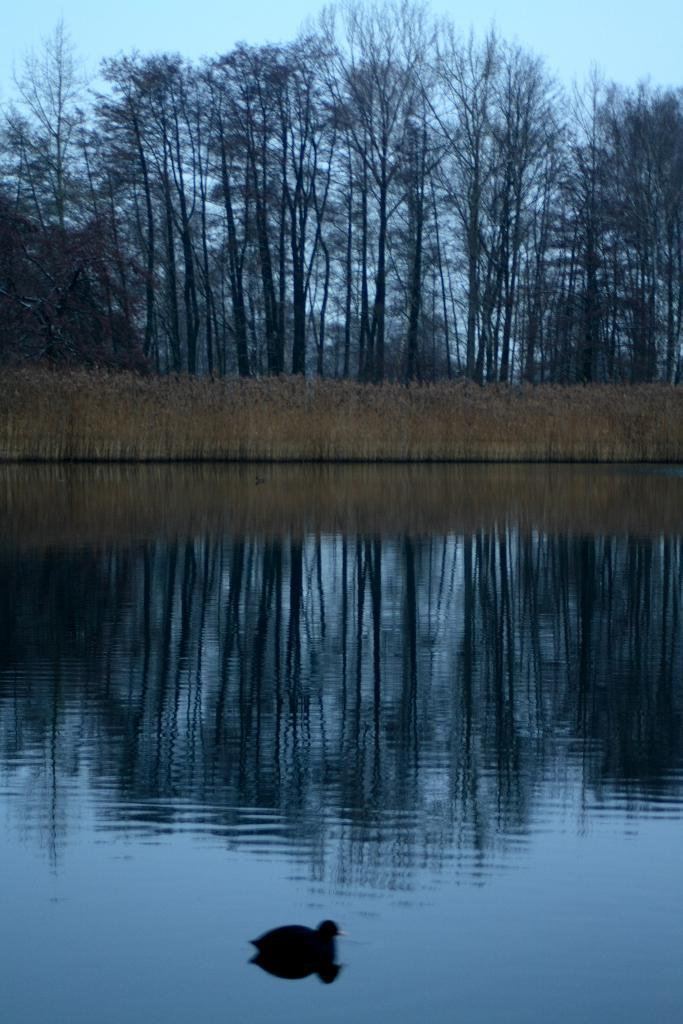What is the primary element present in the image? There is water in the image. What type of animal can be seen in the image? There is a duck in the image. What other living organisms are visible in the image? There are plants and trees in the image. What part of the natural environment is visible in the image? The sky is visible in the image. What type of straw is being used to stir the stew in the image? There is no stew or straw present in the image; it features water, a duck, plants, trees, and the sky. 